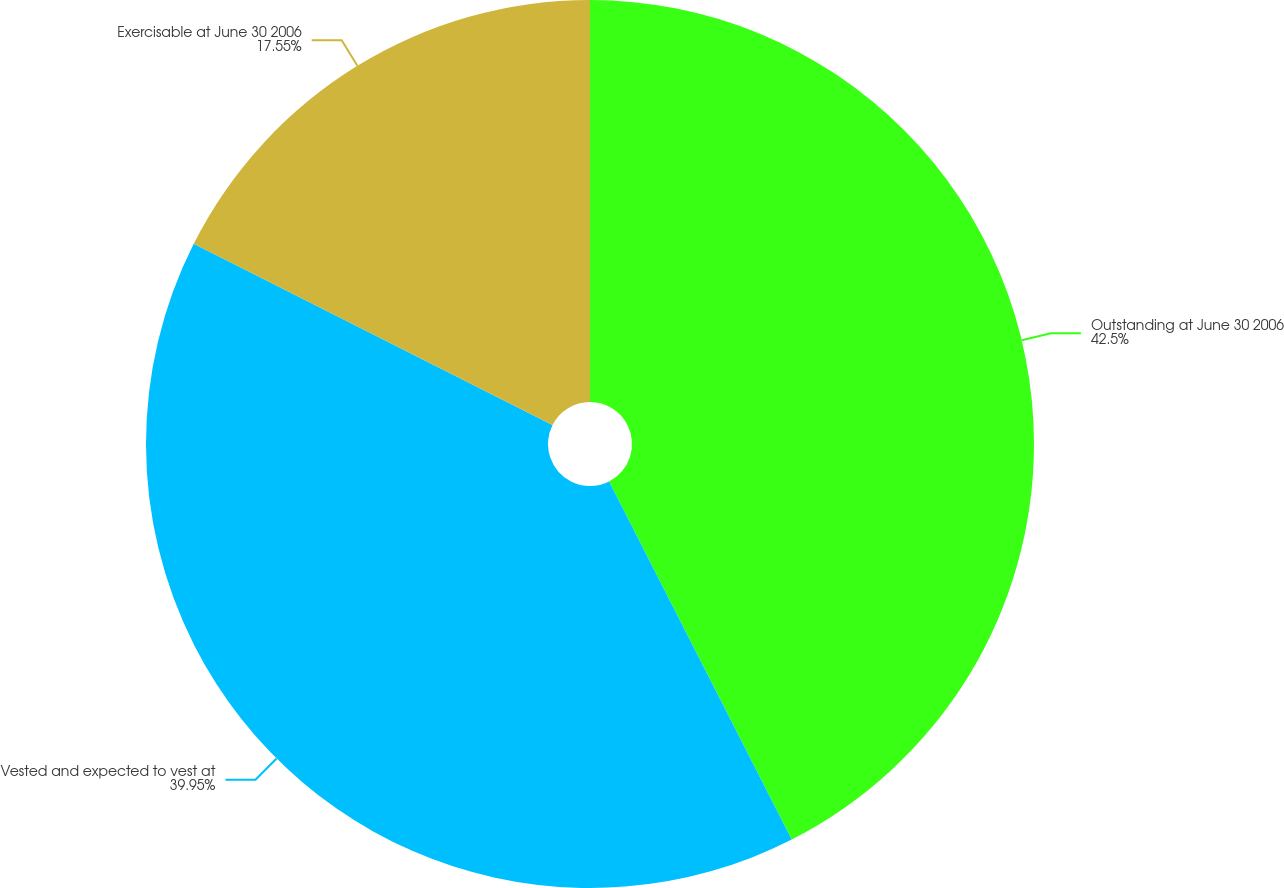<chart> <loc_0><loc_0><loc_500><loc_500><pie_chart><fcel>Outstanding at June 30 2006<fcel>Vested and expected to vest at<fcel>Exercisable at June 30 2006<nl><fcel>42.49%<fcel>39.95%<fcel>17.55%<nl></chart> 